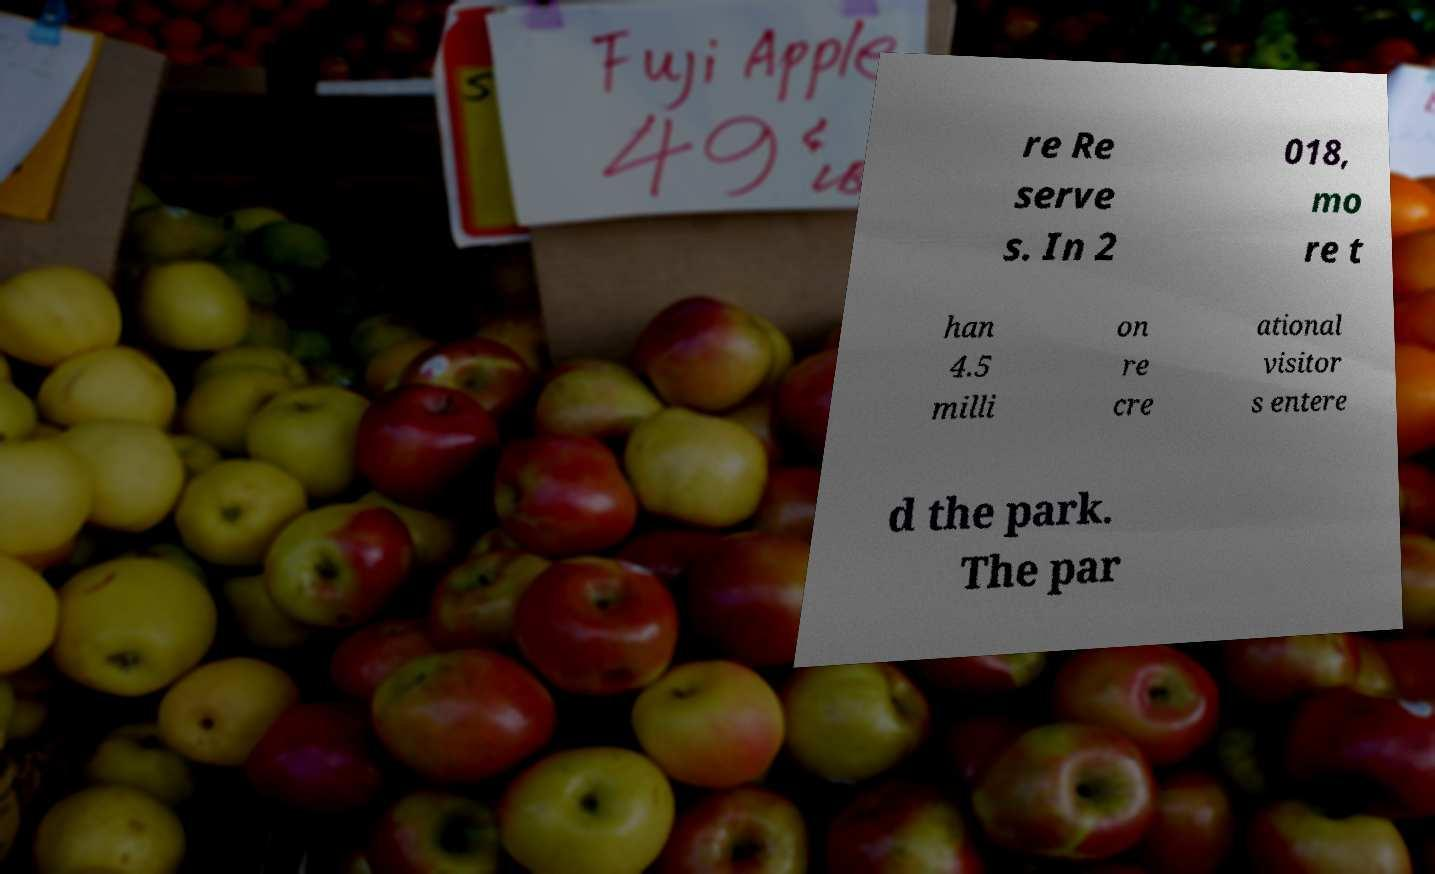What messages or text are displayed in this image? I need them in a readable, typed format. re Re serve s. In 2 018, mo re t han 4.5 milli on re cre ational visitor s entere d the park. The par 